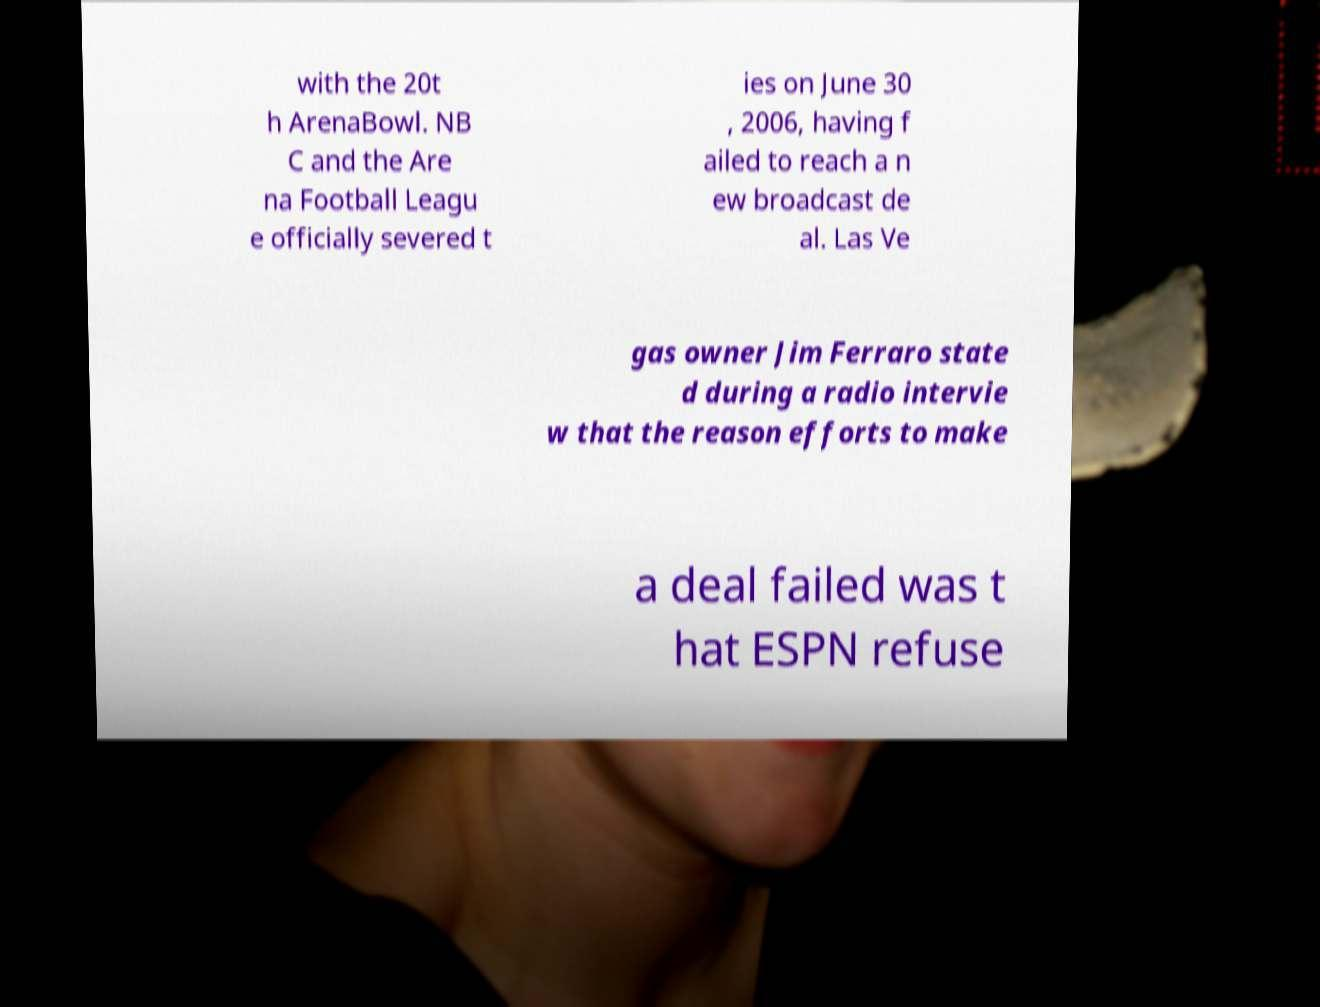What messages or text are displayed in this image? I need them in a readable, typed format. with the 20t h ArenaBowl. NB C and the Are na Football Leagu e officially severed t ies on June 30 , 2006, having f ailed to reach a n ew broadcast de al. Las Ve gas owner Jim Ferraro state d during a radio intervie w that the reason efforts to make a deal failed was t hat ESPN refuse 